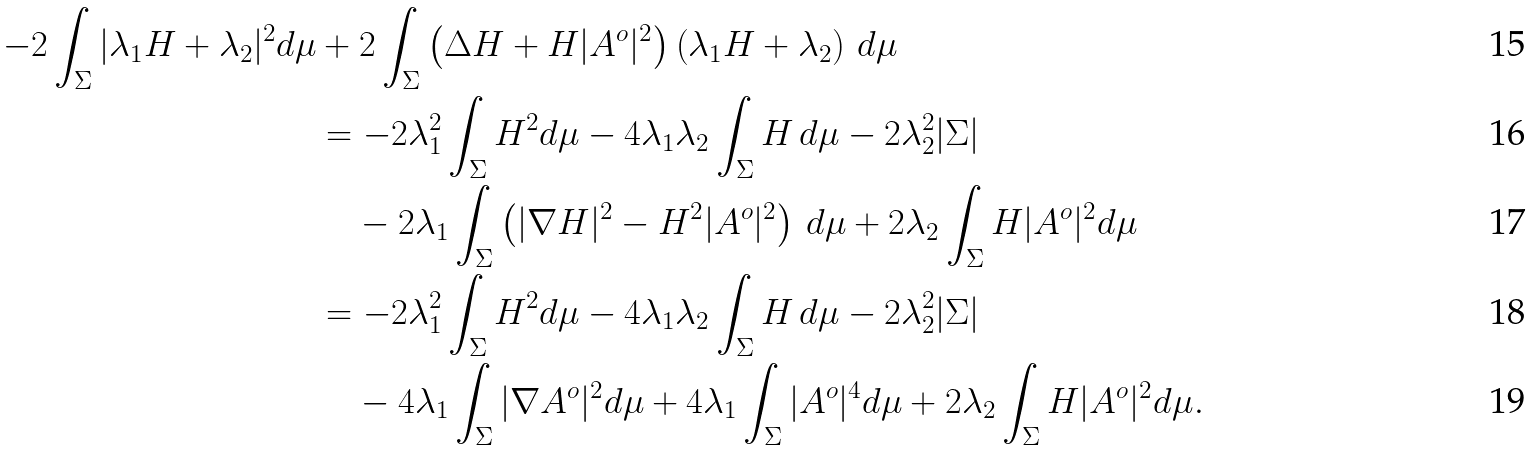Convert formula to latex. <formula><loc_0><loc_0><loc_500><loc_500>- 2 \int _ { \Sigma } | \lambda _ { 1 } H + \lambda _ { 2 } | ^ { 2 } d \mu & + 2 \int _ { \Sigma } \left ( \Delta H + H | A ^ { o } | ^ { 2 } \right ) \left ( \lambda _ { 1 } H + \lambda _ { 2 } \right ) \, d \mu \\ & = - 2 \lambda _ { 1 } ^ { 2 } \int _ { \Sigma } H ^ { 2 } d \mu - 4 \lambda _ { 1 } \lambda _ { 2 } \int _ { \Sigma } H \, d \mu - 2 \lambda _ { 2 } ^ { 2 } | \Sigma | \\ & \quad - 2 \lambda _ { 1 } \int _ { \Sigma } \left ( | \nabla H | ^ { 2 } - H ^ { 2 } | A ^ { o } | ^ { 2 } \right ) \, d \mu + 2 \lambda _ { 2 } \int _ { \Sigma } H | A ^ { o } | ^ { 2 } d \mu \\ & = - 2 \lambda _ { 1 } ^ { 2 } \int _ { \Sigma } H ^ { 2 } d \mu - 4 \lambda _ { 1 } \lambda _ { 2 } \int _ { \Sigma } H \, d \mu - 2 \lambda _ { 2 } ^ { 2 } | \Sigma | \\ & \quad - 4 \lambda _ { 1 } \int _ { \Sigma } | \nabla A ^ { o } | ^ { 2 } d \mu + 4 \lambda _ { 1 } \int _ { \Sigma } | A ^ { o } | ^ { 4 } d \mu + 2 \lambda _ { 2 } \int _ { \Sigma } H | A ^ { o } | ^ { 2 } d \mu .</formula> 